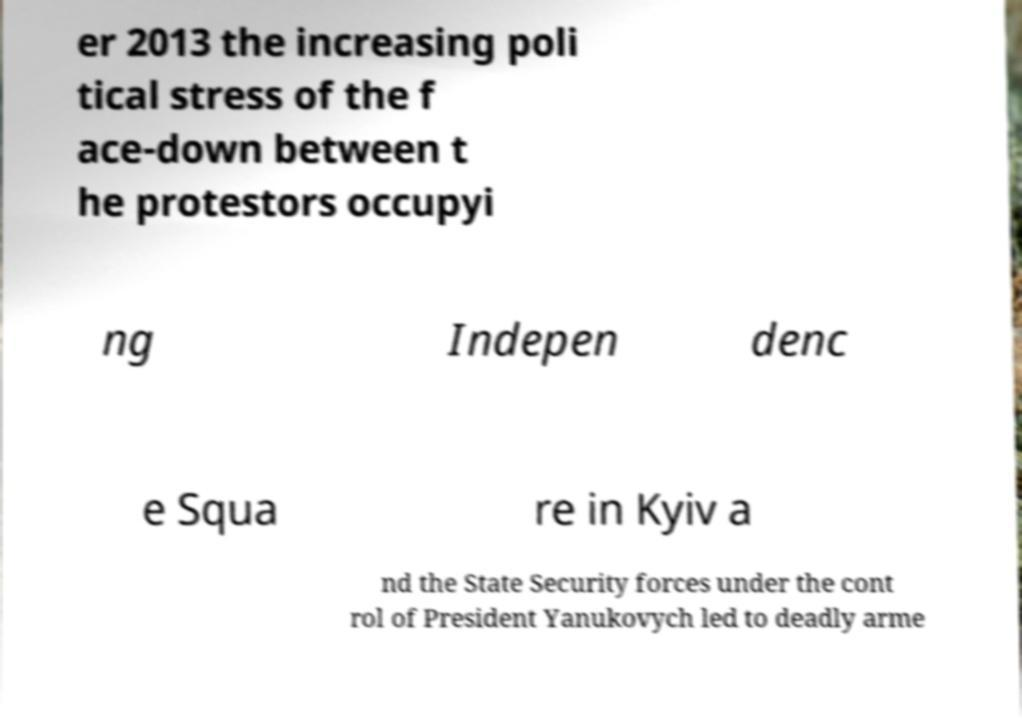Could you assist in decoding the text presented in this image and type it out clearly? er 2013 the increasing poli tical stress of the f ace-down between t he protestors occupyi ng Indepen denc e Squa re in Kyiv a nd the State Security forces under the cont rol of President Yanukovych led to deadly arme 